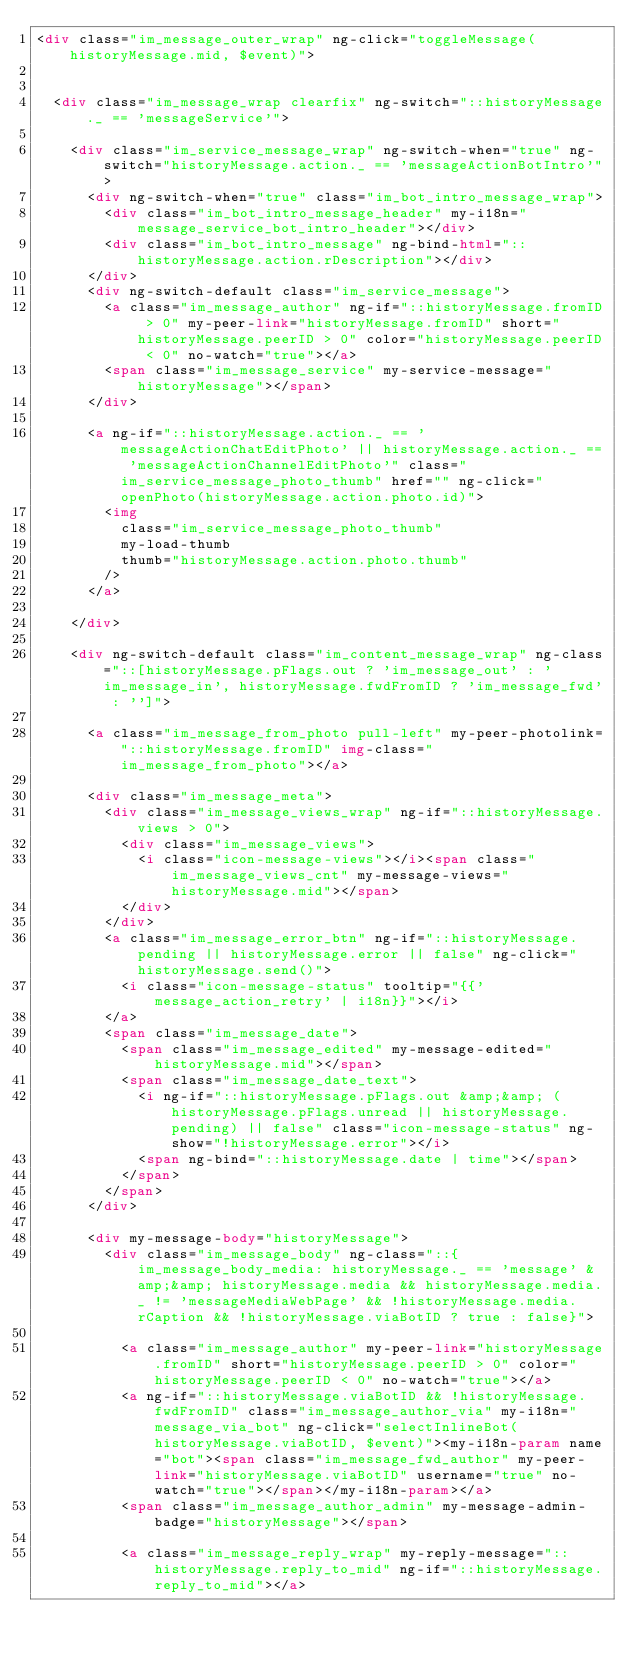<code> <loc_0><loc_0><loc_500><loc_500><_HTML_><div class="im_message_outer_wrap" ng-click="toggleMessage(historyMessage.mid, $event)">


  <div class="im_message_wrap clearfix" ng-switch="::historyMessage._ == 'messageService'">

    <div class="im_service_message_wrap" ng-switch-when="true" ng-switch="historyMessage.action._ == 'messageActionBotIntro'">
      <div ng-switch-when="true" class="im_bot_intro_message_wrap">
        <div class="im_bot_intro_message_header" my-i18n="message_service_bot_intro_header"></div>
        <div class="im_bot_intro_message" ng-bind-html="::historyMessage.action.rDescription"></div>
      </div>
      <div ng-switch-default class="im_service_message">
        <a class="im_message_author" ng-if="::historyMessage.fromID > 0" my-peer-link="historyMessage.fromID" short="historyMessage.peerID > 0" color="historyMessage.peerID < 0" no-watch="true"></a>
        <span class="im_message_service" my-service-message="historyMessage"></span>
      </div>

      <a ng-if="::historyMessage.action._ == 'messageActionChatEditPhoto' || historyMessage.action._ == 'messageActionChannelEditPhoto'" class="im_service_message_photo_thumb" href="" ng-click="openPhoto(historyMessage.action.photo.id)">
        <img
          class="im_service_message_photo_thumb"
          my-load-thumb
          thumb="historyMessage.action.photo.thumb"
        />
      </a>

    </div>

    <div ng-switch-default class="im_content_message_wrap" ng-class="::[historyMessage.pFlags.out ? 'im_message_out' : 'im_message_in', historyMessage.fwdFromID ? 'im_message_fwd' : '']">

      <a class="im_message_from_photo pull-left" my-peer-photolink="::historyMessage.fromID" img-class="im_message_from_photo"></a>

      <div class="im_message_meta">
        <div class="im_message_views_wrap" ng-if="::historyMessage.views > 0">
          <div class="im_message_views">
            <i class="icon-message-views"></i><span class="im_message_views_cnt" my-message-views="historyMessage.mid"></span>
          </div>
        </div>
        <a class="im_message_error_btn" ng-if="::historyMessage.pending || historyMessage.error || false" ng-click="historyMessage.send()">
          <i class="icon-message-status" tooltip="{{'message_action_retry' | i18n}}"></i>
        </a>
        <span class="im_message_date">
          <span class="im_message_edited" my-message-edited="historyMessage.mid"></span>
          <span class="im_message_date_text">
            <i ng-if="::historyMessage.pFlags.out &amp;&amp; (historyMessage.pFlags.unread || historyMessage.pending) || false" class="icon-message-status" ng-show="!historyMessage.error"></i>
            <span ng-bind="::historyMessage.date | time"></span>
          </span>
        </span>
      </div>

      <div my-message-body="historyMessage">
        <div class="im_message_body" ng-class="::{im_message_body_media: historyMessage._ == 'message' &amp;&amp; historyMessage.media && historyMessage.media._ != 'messageMediaWebPage' && !historyMessage.media.rCaption && !historyMessage.viaBotID ? true : false}">

          <a class="im_message_author" my-peer-link="historyMessage.fromID" short="historyMessage.peerID > 0" color="historyMessage.peerID < 0" no-watch="true"></a>
          <a ng-if="::historyMessage.viaBotID && !historyMessage.fwdFromID" class="im_message_author_via" my-i18n="message_via_bot" ng-click="selectInlineBot(historyMessage.viaBotID, $event)"><my-i18n-param name="bot"><span class="im_message_fwd_author" my-peer-link="historyMessage.viaBotID" username="true" no-watch="true"></span></my-i18n-param></a>
          <span class="im_message_author_admin" my-message-admin-badge="historyMessage"></span>

          <a class="im_message_reply_wrap" my-reply-message="::historyMessage.reply_to_mid" ng-if="::historyMessage.reply_to_mid"></a>
</code> 